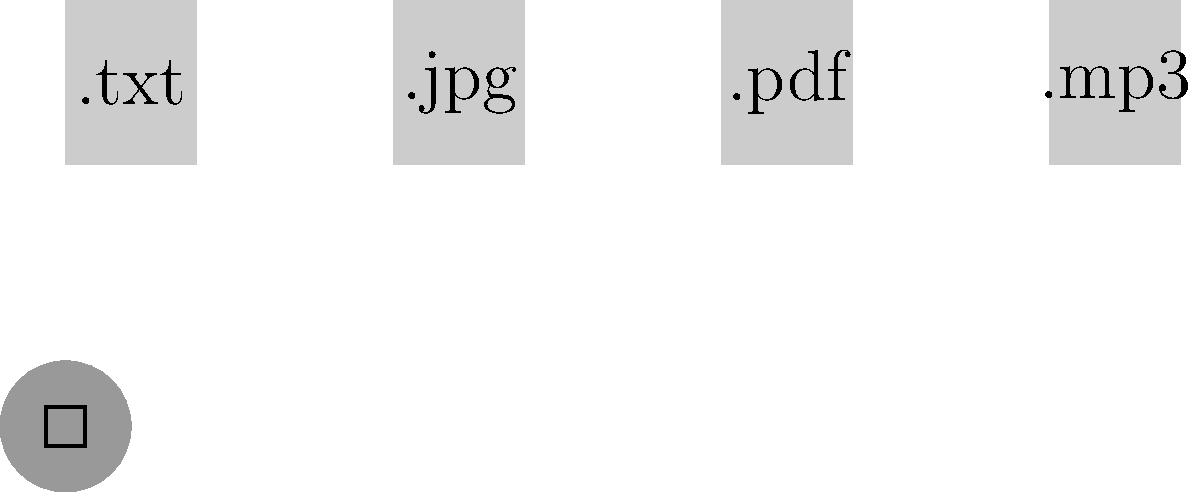Match the file extensions to their corresponding icons. Which file extension is associated with the musical note icon? To answer this question, let's analyze the image and follow these steps:

1. Identify the file extensions shown:
   - .txt
   - .jpg
   - .pdf
   - .mp3

2. Identify the icons shown:
   - A document icon (simple rectangle)
   - A photo icon (rectangle with a plus sign)
   - A PDF icon (stylized letter P)
   - A musical note icon

3. Match the extensions to their typical uses:
   - .txt is commonly used for text documents
   - .jpg is used for image files
   - .pdf is used for Portable Document Format files
   - .mp3 is used for audio files

4. Connect the icons to their typical uses:
   - The document icon represents text files
   - The photo icon represents image files
   - The PDF icon represents PDF files
   - The musical note icon represents audio files

5. Observe the dashed lines in the image, which correctly match:
   - .txt with the document icon
   - .jpg with the photo icon
   - .pdf with the PDF icon
   - .mp3 with the musical note icon

Therefore, the file extension associated with the musical note icon is .mp3.
Answer: .mp3 